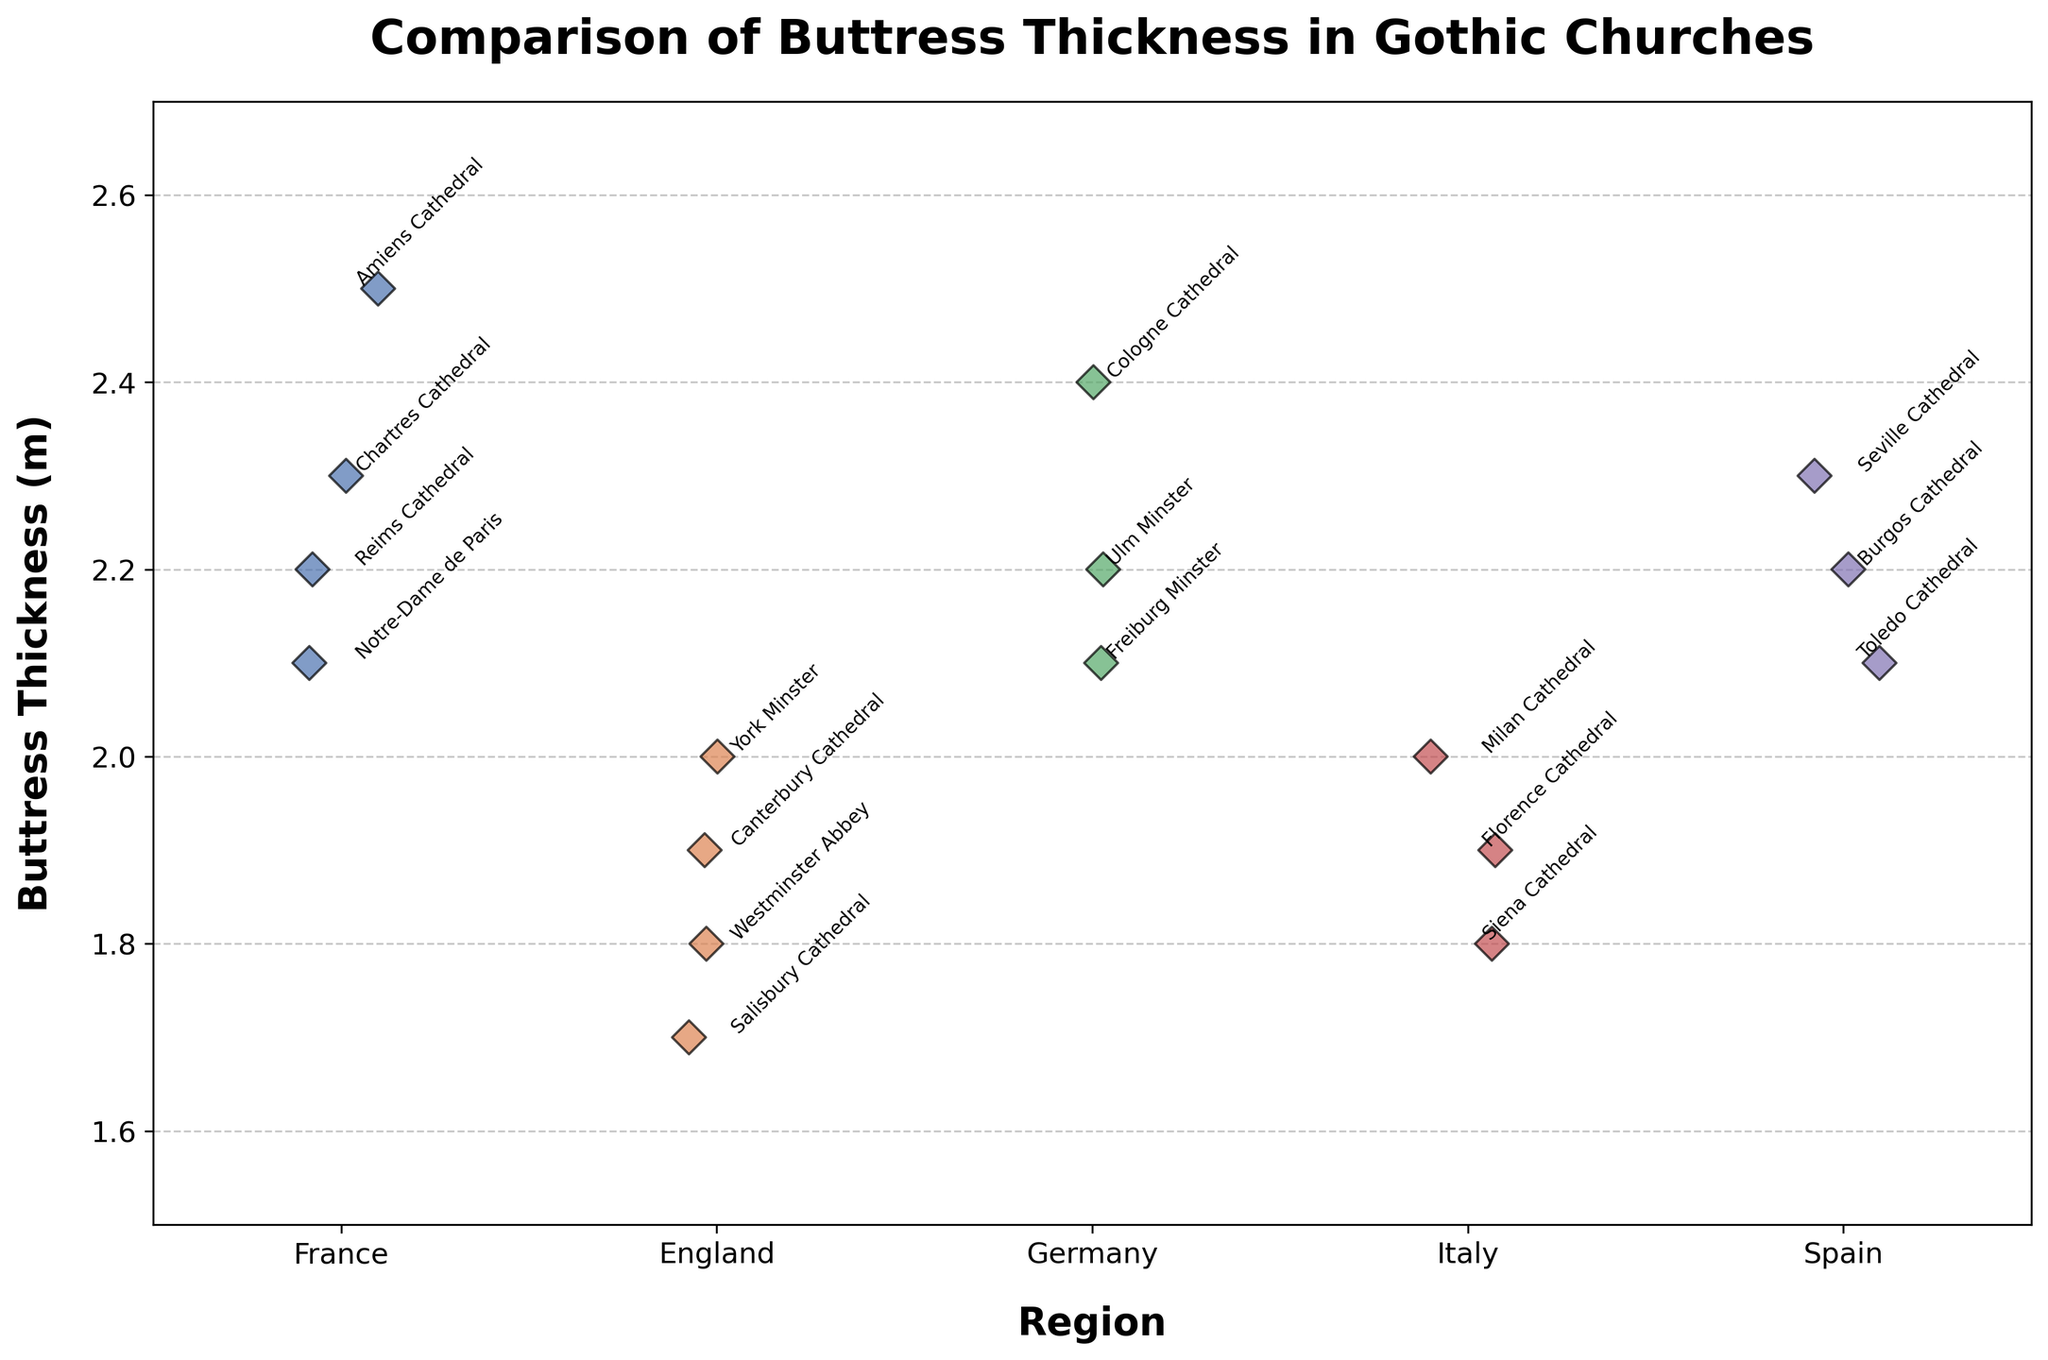Which region has the church with the thickest buttress? To find the region with the thickest buttress, locate the highest data point on the y-axis. The highest buttress thickness is 2.5 meters, which belongs to Amiens Cathedral in France.
Answer: France What is the range of buttress thicknesses in German churches? Identify the lowest and highest buttress thicknesses for the German churches. The data points for Germany are Cologne Cathedral (2.4), Ulm Minster (2.2), and Freiburg Minster (2.1), so the range is 2.4 - 2.1 = 0.3.
Answer: 0.3 Are there more churches with buttresses thicker than 2.3 meters in France or in Spain? Count the churches with buttresses thicker than 2.3 meters in each region. In France, only Amiens Cathedral has a buttress thickness of 2.5 meters. In Spain, Seville Cathedral has a thickness of 2.3 meters, which is not greater than 2.3. Therefore, neither region has more than the other since they both have one.
Answer: Neither Which Italian church has the thinnest buttress? Compare the thickness values for the Italian churches. They are Milan Cathedral (2.0), Florence Cathedral (1.9), and Siena Cathedral (1.8). The thinnest buttress is 1.8 meters, which belongs to Siena Cathedral.
Answer: Siena Cathedral How does the average buttress thickness of English churches compare to that of Spanish churches? Calculate the average buttress thickness for both regions. The English churches have thicknesses of 1.8, 2.0, 1.9, and 1.7. The average is (1.8 + 2.0 + 1.9 + 1.7) / 4 = 1.85. The Spanish churches have thicknesses of 2.3, 2.1, and 2.2. The average is (2.3 + 2.1 + 2.2) / 3 = 2.2. Thus, the average buttress thickness in Spanish churches is greater.
Answer: Spanish average is greater Which church in the 'Spain' region has the thickest buttress? Look at the data points for the Spanish region churches. The points are Seville Cathedral (2.3), Toledo Cathedral (2.1), and Burgos Cathedral (2.2). The thickest buttress is 2.3 meters, belonging to Seville Cathedral.
Answer: Seville Cathedral Is there more variability in buttress thickness among French or German churches? Evaluate the spread of data points for French and German churches. For Germany, the thicknesses are 2.4, 2.2, and 2.1, with a small spread. For France, the thicknesses are 2.1, 2.3, 2.5, and 2.2, which show a larger spread. France has more variability.
Answer: France What is the difference in the thickest and thinnest buttress in Italian Gothic churches? Determine the maximum and minimum buttress thicknesses for Italian churches. The values are 2.0, 1.9, and 1.8. So, the difference is 2.0 - 1.8 = 0.2 meters.
Answer: 0.2 meters 